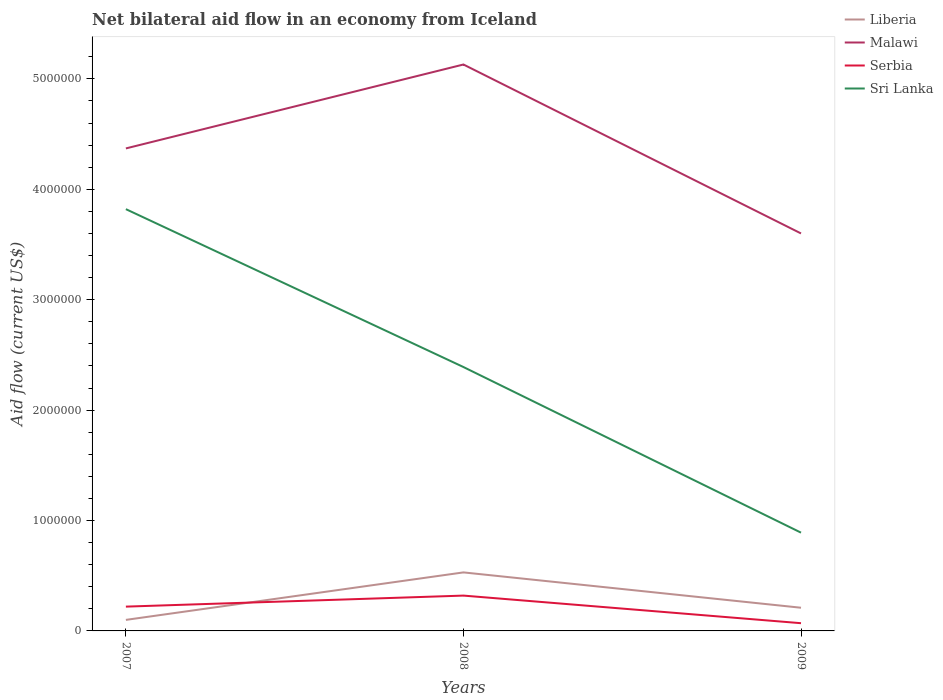Does the line corresponding to Sri Lanka intersect with the line corresponding to Liberia?
Your answer should be very brief. No. Is the number of lines equal to the number of legend labels?
Your answer should be very brief. Yes. In which year was the net bilateral aid flow in Liberia maximum?
Your answer should be very brief. 2007. What is the total net bilateral aid flow in Malawi in the graph?
Provide a succinct answer. 7.70e+05. What is the difference between the highest and the second highest net bilateral aid flow in Sri Lanka?
Give a very brief answer. 2.93e+06. What is the difference between the highest and the lowest net bilateral aid flow in Liberia?
Keep it short and to the point. 1. Is the net bilateral aid flow in Malawi strictly greater than the net bilateral aid flow in Serbia over the years?
Your answer should be compact. No. Are the values on the major ticks of Y-axis written in scientific E-notation?
Make the answer very short. No. Does the graph contain any zero values?
Offer a very short reply. No. Does the graph contain grids?
Your response must be concise. No. What is the title of the graph?
Your answer should be compact. Net bilateral aid flow in an economy from Iceland. Does "Portugal" appear as one of the legend labels in the graph?
Make the answer very short. No. What is the Aid flow (current US$) in Liberia in 2007?
Your answer should be very brief. 1.00e+05. What is the Aid flow (current US$) of Malawi in 2007?
Your answer should be very brief. 4.37e+06. What is the Aid flow (current US$) in Serbia in 2007?
Offer a very short reply. 2.20e+05. What is the Aid flow (current US$) of Sri Lanka in 2007?
Make the answer very short. 3.82e+06. What is the Aid flow (current US$) in Liberia in 2008?
Offer a terse response. 5.30e+05. What is the Aid flow (current US$) in Malawi in 2008?
Make the answer very short. 5.13e+06. What is the Aid flow (current US$) in Sri Lanka in 2008?
Keep it short and to the point. 2.39e+06. What is the Aid flow (current US$) of Malawi in 2009?
Ensure brevity in your answer.  3.60e+06. What is the Aid flow (current US$) of Sri Lanka in 2009?
Your answer should be compact. 8.90e+05. Across all years, what is the maximum Aid flow (current US$) of Liberia?
Your answer should be very brief. 5.30e+05. Across all years, what is the maximum Aid flow (current US$) of Malawi?
Provide a short and direct response. 5.13e+06. Across all years, what is the maximum Aid flow (current US$) in Serbia?
Offer a terse response. 3.20e+05. Across all years, what is the maximum Aid flow (current US$) in Sri Lanka?
Your response must be concise. 3.82e+06. Across all years, what is the minimum Aid flow (current US$) of Malawi?
Your answer should be compact. 3.60e+06. Across all years, what is the minimum Aid flow (current US$) in Serbia?
Provide a short and direct response. 7.00e+04. Across all years, what is the minimum Aid flow (current US$) in Sri Lanka?
Your answer should be very brief. 8.90e+05. What is the total Aid flow (current US$) of Liberia in the graph?
Ensure brevity in your answer.  8.40e+05. What is the total Aid flow (current US$) in Malawi in the graph?
Make the answer very short. 1.31e+07. What is the total Aid flow (current US$) in Sri Lanka in the graph?
Provide a succinct answer. 7.10e+06. What is the difference between the Aid flow (current US$) in Liberia in 2007 and that in 2008?
Keep it short and to the point. -4.30e+05. What is the difference between the Aid flow (current US$) in Malawi in 2007 and that in 2008?
Give a very brief answer. -7.60e+05. What is the difference between the Aid flow (current US$) of Sri Lanka in 2007 and that in 2008?
Offer a very short reply. 1.43e+06. What is the difference between the Aid flow (current US$) of Malawi in 2007 and that in 2009?
Make the answer very short. 7.70e+05. What is the difference between the Aid flow (current US$) in Serbia in 2007 and that in 2009?
Give a very brief answer. 1.50e+05. What is the difference between the Aid flow (current US$) in Sri Lanka in 2007 and that in 2009?
Offer a very short reply. 2.93e+06. What is the difference between the Aid flow (current US$) in Malawi in 2008 and that in 2009?
Provide a short and direct response. 1.53e+06. What is the difference between the Aid flow (current US$) of Serbia in 2008 and that in 2009?
Your answer should be compact. 2.50e+05. What is the difference between the Aid flow (current US$) of Sri Lanka in 2008 and that in 2009?
Your response must be concise. 1.50e+06. What is the difference between the Aid flow (current US$) of Liberia in 2007 and the Aid flow (current US$) of Malawi in 2008?
Offer a very short reply. -5.03e+06. What is the difference between the Aid flow (current US$) of Liberia in 2007 and the Aid flow (current US$) of Sri Lanka in 2008?
Ensure brevity in your answer.  -2.29e+06. What is the difference between the Aid flow (current US$) in Malawi in 2007 and the Aid flow (current US$) in Serbia in 2008?
Give a very brief answer. 4.05e+06. What is the difference between the Aid flow (current US$) in Malawi in 2007 and the Aid flow (current US$) in Sri Lanka in 2008?
Provide a short and direct response. 1.98e+06. What is the difference between the Aid flow (current US$) in Serbia in 2007 and the Aid flow (current US$) in Sri Lanka in 2008?
Your answer should be compact. -2.17e+06. What is the difference between the Aid flow (current US$) of Liberia in 2007 and the Aid flow (current US$) of Malawi in 2009?
Offer a terse response. -3.50e+06. What is the difference between the Aid flow (current US$) in Liberia in 2007 and the Aid flow (current US$) in Serbia in 2009?
Make the answer very short. 3.00e+04. What is the difference between the Aid flow (current US$) of Liberia in 2007 and the Aid flow (current US$) of Sri Lanka in 2009?
Offer a very short reply. -7.90e+05. What is the difference between the Aid flow (current US$) in Malawi in 2007 and the Aid flow (current US$) in Serbia in 2009?
Make the answer very short. 4.30e+06. What is the difference between the Aid flow (current US$) in Malawi in 2007 and the Aid flow (current US$) in Sri Lanka in 2009?
Give a very brief answer. 3.48e+06. What is the difference between the Aid flow (current US$) of Serbia in 2007 and the Aid flow (current US$) of Sri Lanka in 2009?
Your response must be concise. -6.70e+05. What is the difference between the Aid flow (current US$) in Liberia in 2008 and the Aid flow (current US$) in Malawi in 2009?
Make the answer very short. -3.07e+06. What is the difference between the Aid flow (current US$) of Liberia in 2008 and the Aid flow (current US$) of Sri Lanka in 2009?
Your answer should be compact. -3.60e+05. What is the difference between the Aid flow (current US$) in Malawi in 2008 and the Aid flow (current US$) in Serbia in 2009?
Keep it short and to the point. 5.06e+06. What is the difference between the Aid flow (current US$) of Malawi in 2008 and the Aid flow (current US$) of Sri Lanka in 2009?
Provide a short and direct response. 4.24e+06. What is the difference between the Aid flow (current US$) of Serbia in 2008 and the Aid flow (current US$) of Sri Lanka in 2009?
Make the answer very short. -5.70e+05. What is the average Aid flow (current US$) of Liberia per year?
Your answer should be very brief. 2.80e+05. What is the average Aid flow (current US$) of Malawi per year?
Provide a short and direct response. 4.37e+06. What is the average Aid flow (current US$) in Serbia per year?
Offer a terse response. 2.03e+05. What is the average Aid flow (current US$) in Sri Lanka per year?
Ensure brevity in your answer.  2.37e+06. In the year 2007, what is the difference between the Aid flow (current US$) in Liberia and Aid flow (current US$) in Malawi?
Provide a succinct answer. -4.27e+06. In the year 2007, what is the difference between the Aid flow (current US$) in Liberia and Aid flow (current US$) in Sri Lanka?
Keep it short and to the point. -3.72e+06. In the year 2007, what is the difference between the Aid flow (current US$) of Malawi and Aid flow (current US$) of Serbia?
Provide a short and direct response. 4.15e+06. In the year 2007, what is the difference between the Aid flow (current US$) of Malawi and Aid flow (current US$) of Sri Lanka?
Your answer should be very brief. 5.50e+05. In the year 2007, what is the difference between the Aid flow (current US$) of Serbia and Aid flow (current US$) of Sri Lanka?
Your response must be concise. -3.60e+06. In the year 2008, what is the difference between the Aid flow (current US$) in Liberia and Aid flow (current US$) in Malawi?
Provide a short and direct response. -4.60e+06. In the year 2008, what is the difference between the Aid flow (current US$) in Liberia and Aid flow (current US$) in Serbia?
Ensure brevity in your answer.  2.10e+05. In the year 2008, what is the difference between the Aid flow (current US$) in Liberia and Aid flow (current US$) in Sri Lanka?
Keep it short and to the point. -1.86e+06. In the year 2008, what is the difference between the Aid flow (current US$) of Malawi and Aid flow (current US$) of Serbia?
Your response must be concise. 4.81e+06. In the year 2008, what is the difference between the Aid flow (current US$) in Malawi and Aid flow (current US$) in Sri Lanka?
Offer a terse response. 2.74e+06. In the year 2008, what is the difference between the Aid flow (current US$) in Serbia and Aid flow (current US$) in Sri Lanka?
Provide a short and direct response. -2.07e+06. In the year 2009, what is the difference between the Aid flow (current US$) in Liberia and Aid flow (current US$) in Malawi?
Make the answer very short. -3.39e+06. In the year 2009, what is the difference between the Aid flow (current US$) in Liberia and Aid flow (current US$) in Sri Lanka?
Your answer should be very brief. -6.80e+05. In the year 2009, what is the difference between the Aid flow (current US$) in Malawi and Aid flow (current US$) in Serbia?
Provide a succinct answer. 3.53e+06. In the year 2009, what is the difference between the Aid flow (current US$) of Malawi and Aid flow (current US$) of Sri Lanka?
Offer a terse response. 2.71e+06. In the year 2009, what is the difference between the Aid flow (current US$) in Serbia and Aid flow (current US$) in Sri Lanka?
Offer a very short reply. -8.20e+05. What is the ratio of the Aid flow (current US$) in Liberia in 2007 to that in 2008?
Give a very brief answer. 0.19. What is the ratio of the Aid flow (current US$) in Malawi in 2007 to that in 2008?
Provide a short and direct response. 0.85. What is the ratio of the Aid flow (current US$) in Serbia in 2007 to that in 2008?
Your answer should be very brief. 0.69. What is the ratio of the Aid flow (current US$) of Sri Lanka in 2007 to that in 2008?
Your answer should be compact. 1.6. What is the ratio of the Aid flow (current US$) of Liberia in 2007 to that in 2009?
Your answer should be very brief. 0.48. What is the ratio of the Aid flow (current US$) in Malawi in 2007 to that in 2009?
Provide a succinct answer. 1.21. What is the ratio of the Aid flow (current US$) of Serbia in 2007 to that in 2009?
Ensure brevity in your answer.  3.14. What is the ratio of the Aid flow (current US$) in Sri Lanka in 2007 to that in 2009?
Offer a very short reply. 4.29. What is the ratio of the Aid flow (current US$) of Liberia in 2008 to that in 2009?
Make the answer very short. 2.52. What is the ratio of the Aid flow (current US$) of Malawi in 2008 to that in 2009?
Ensure brevity in your answer.  1.43. What is the ratio of the Aid flow (current US$) of Serbia in 2008 to that in 2009?
Your answer should be compact. 4.57. What is the ratio of the Aid flow (current US$) in Sri Lanka in 2008 to that in 2009?
Offer a very short reply. 2.69. What is the difference between the highest and the second highest Aid flow (current US$) of Malawi?
Provide a succinct answer. 7.60e+05. What is the difference between the highest and the second highest Aid flow (current US$) in Serbia?
Give a very brief answer. 1.00e+05. What is the difference between the highest and the second highest Aid flow (current US$) in Sri Lanka?
Your answer should be compact. 1.43e+06. What is the difference between the highest and the lowest Aid flow (current US$) of Liberia?
Provide a succinct answer. 4.30e+05. What is the difference between the highest and the lowest Aid flow (current US$) in Malawi?
Offer a terse response. 1.53e+06. What is the difference between the highest and the lowest Aid flow (current US$) of Sri Lanka?
Give a very brief answer. 2.93e+06. 